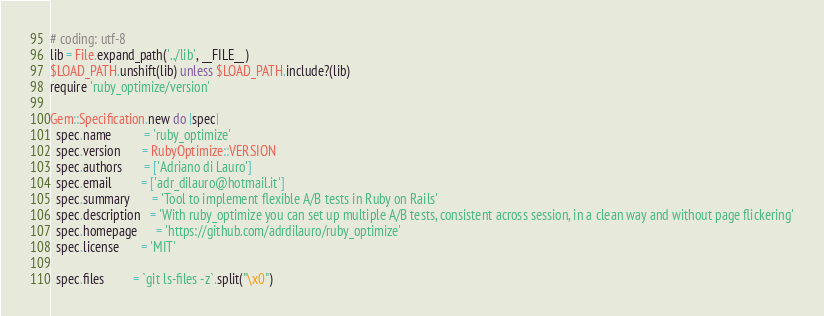Convert code to text. <code><loc_0><loc_0><loc_500><loc_500><_Ruby_># coding: utf-8
lib = File.expand_path('../lib', __FILE__)
$LOAD_PATH.unshift(lib) unless $LOAD_PATH.include?(lib)
require 'ruby_optimize/version'

Gem::Specification.new do |spec|
  spec.name          = 'ruby_optimize'
  spec.version       = RubyOptimize::VERSION
  spec.authors       = ['Adriano di Lauro']
  spec.email         = ['adr_dilauro@hotmail.it']
  spec.summary       = 'Tool to implement flexible A/B tests in Ruby on Rails'
  spec.description   = 'With ruby_optimize you can set up multiple A/B tests, consistent across session, in a clean way and without page flickering'
  spec.homepage      = 'https://github.com/adrdilauro/ruby_optimize'
  spec.license       = 'MIT'

  spec.files         = `git ls-files -z`.split("\x0")</code> 